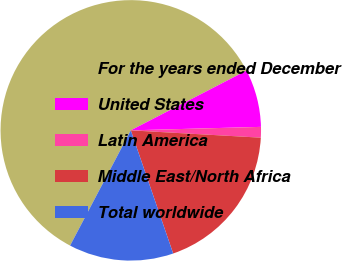Convert chart to OTSL. <chart><loc_0><loc_0><loc_500><loc_500><pie_chart><fcel>For the years ended December<fcel>United States<fcel>Latin America<fcel>Middle East/North Africa<fcel>Total worldwide<nl><fcel>59.7%<fcel>7.16%<fcel>1.32%<fcel>18.83%<fcel>12.99%<nl></chart> 